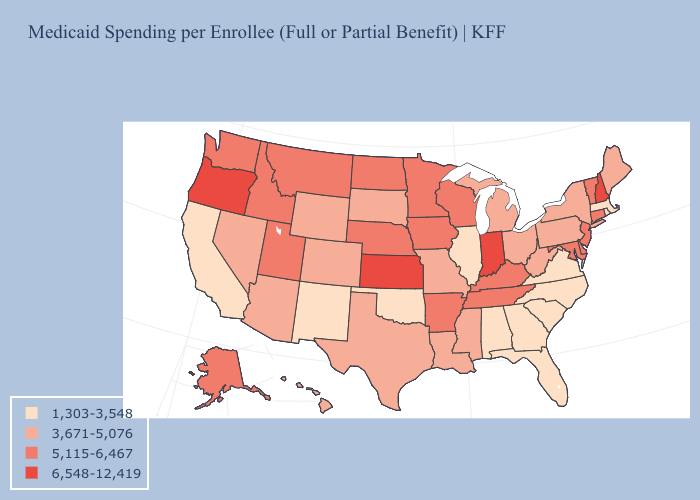What is the highest value in the USA?
Keep it brief. 6,548-12,419. Is the legend a continuous bar?
Write a very short answer. No. Does Oregon have the highest value in the USA?
Answer briefly. Yes. What is the highest value in the West ?
Quick response, please. 6,548-12,419. What is the value of Florida?
Be succinct. 1,303-3,548. Does New Mexico have a lower value than Nebraska?
Short answer required. Yes. What is the lowest value in states that border Virginia?
Write a very short answer. 1,303-3,548. What is the highest value in states that border New York?
Write a very short answer. 5,115-6,467. Which states have the highest value in the USA?
Give a very brief answer. Indiana, Kansas, New Hampshire, Oregon. Name the states that have a value in the range 3,671-5,076?
Write a very short answer. Arizona, Colorado, Hawaii, Louisiana, Maine, Michigan, Mississippi, Missouri, Nevada, New York, Ohio, Pennsylvania, South Dakota, Texas, West Virginia, Wyoming. Which states have the highest value in the USA?
Quick response, please. Indiana, Kansas, New Hampshire, Oregon. What is the value of Alaska?
Write a very short answer. 5,115-6,467. Name the states that have a value in the range 6,548-12,419?
Write a very short answer. Indiana, Kansas, New Hampshire, Oregon. Does Oregon have the highest value in the West?
Short answer required. Yes. What is the value of Missouri?
Concise answer only. 3,671-5,076. 